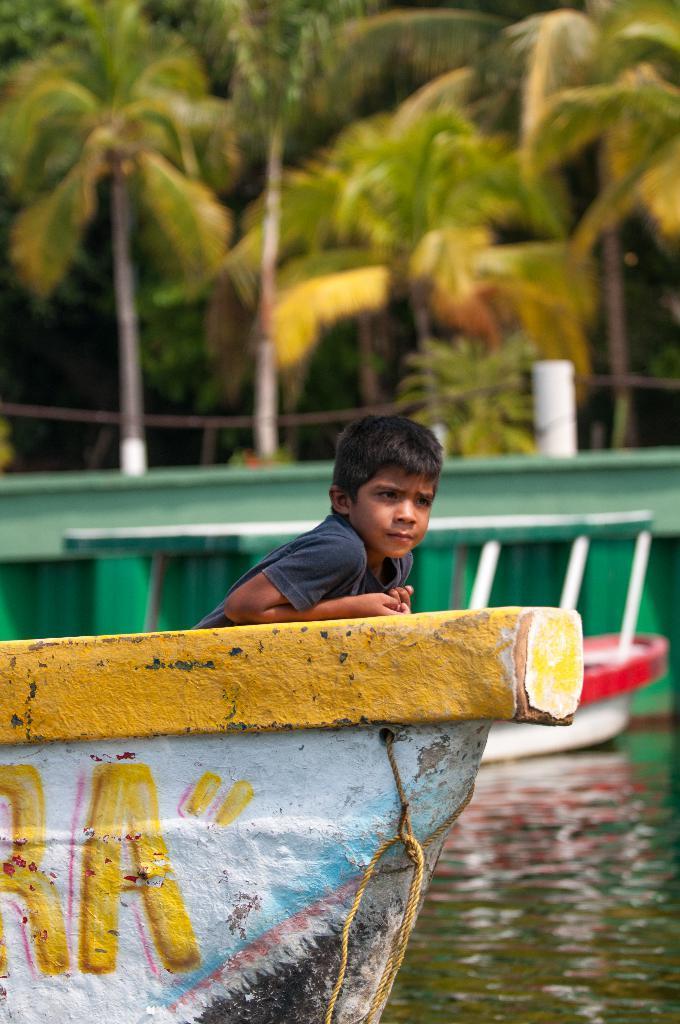Please provide a concise description of this image. In this image we can see two boats on the water and a boy on the boat, in the background there is a wall and few trees. 